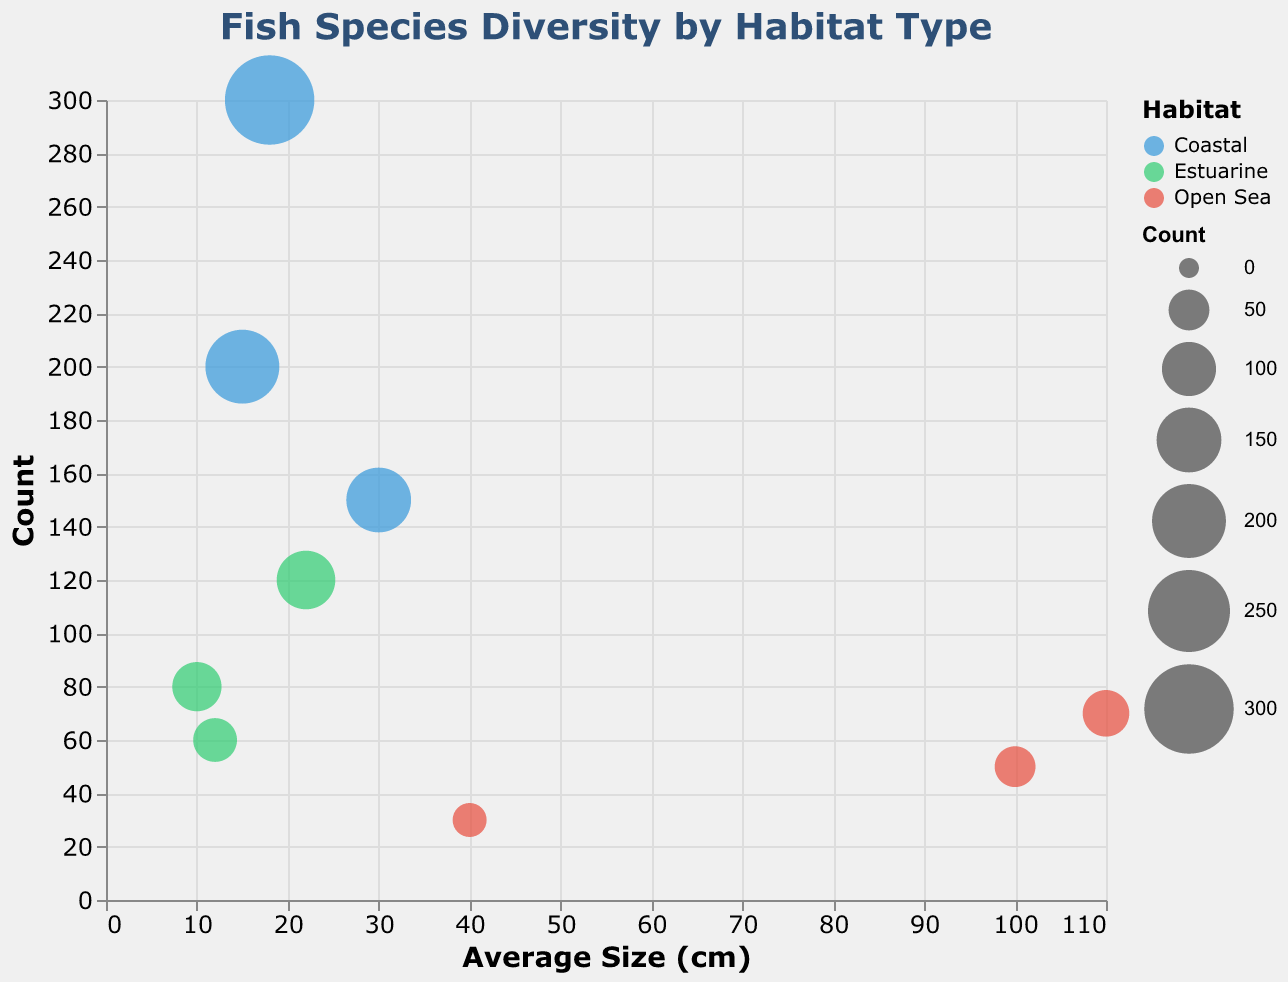How many fish species in the plot are classified as "Least Concern"? To determine the number of "Least Concern" species, we need to look at the legend and count the circles labeled with this status. The habitat types and colors can help identify them.
Answer: 6 Which habitat has the highest count of fish for a single species, and what is that count? Refer to the y-axis (Count) and identify the bubble with the highest value within each habitat group. Compare the highest values: Coastal (300 for Korean Sandlance), Estuarine (120 for Sailfin Sandfish), Open Sea (70 for Korean Moray).
Answer: Coastal, 300 What is the average size and count of fish for the species with the smallest average size in the coastal habitat? Find the coastal species with the smallest bubble on the x-axis (Average Size). Goby has an average size of 15 cm and a count of 200.
Answer: 15 cm, 200 How many species in the chart are more than 100 cm in average size, and what are their protection statuses? Find the species with average sizes greater than 100 cm on the x-axis. Two species: Dorsal-Fin Conger (Vulnerable), Korean Moray (Least Concern).
Answer: 2, Vulnerable and Least Concern Which species has the largest bubble in the Estuarine habitat, indicating the highest count, and what is its average size? The largest bubble in the Estuarine habitat relates to the species with the highest count. Look for the biggest bubble in green; it corresponds to the Sailfin Sandfish, which has an average size of 22 cm.
Answer: Sailfin Sandfish, 22 cm Which habitat contains the species with the largest average size, and what is that size? Check on the x-axis (Average Size) for the bubble farthest to the right for each habitat. The Open Sea habitat has the Korean Moray with an average size of 110 cm.
Answer: Open Sea, 110 cm What is the combined count of all species in the Open Sea habitat? Add the counts of all the species in the Open Sea habitat by summing the Count values for the circles colored red: 50 (Dorsal-Fin Conger) + 70 (Korean Moray) + 30 (Plagiogeneion fiolenti).
Answer: 150 Which species is listed as "Near Threatened" in the Estuarine habitat, and what is its count? Refer to the tooltip for species in the Estuarine habitat to find which one is "Near Threatened". The Korean Stumpy Bullhead is "Near Threatened" with a count of 80.
Answer: Korean Stumpy Bullhead, 80 What's the difference in average size between the largest and the smallest species in the Open Sea habitat? Identify the Open Sea species with the largest (Korean Moray, 110 cm) and smallest (Plagiogeneion fiolenti, 40 cm) average sizes and compute the difference: 110 - 40.
Answer: 70 cm 